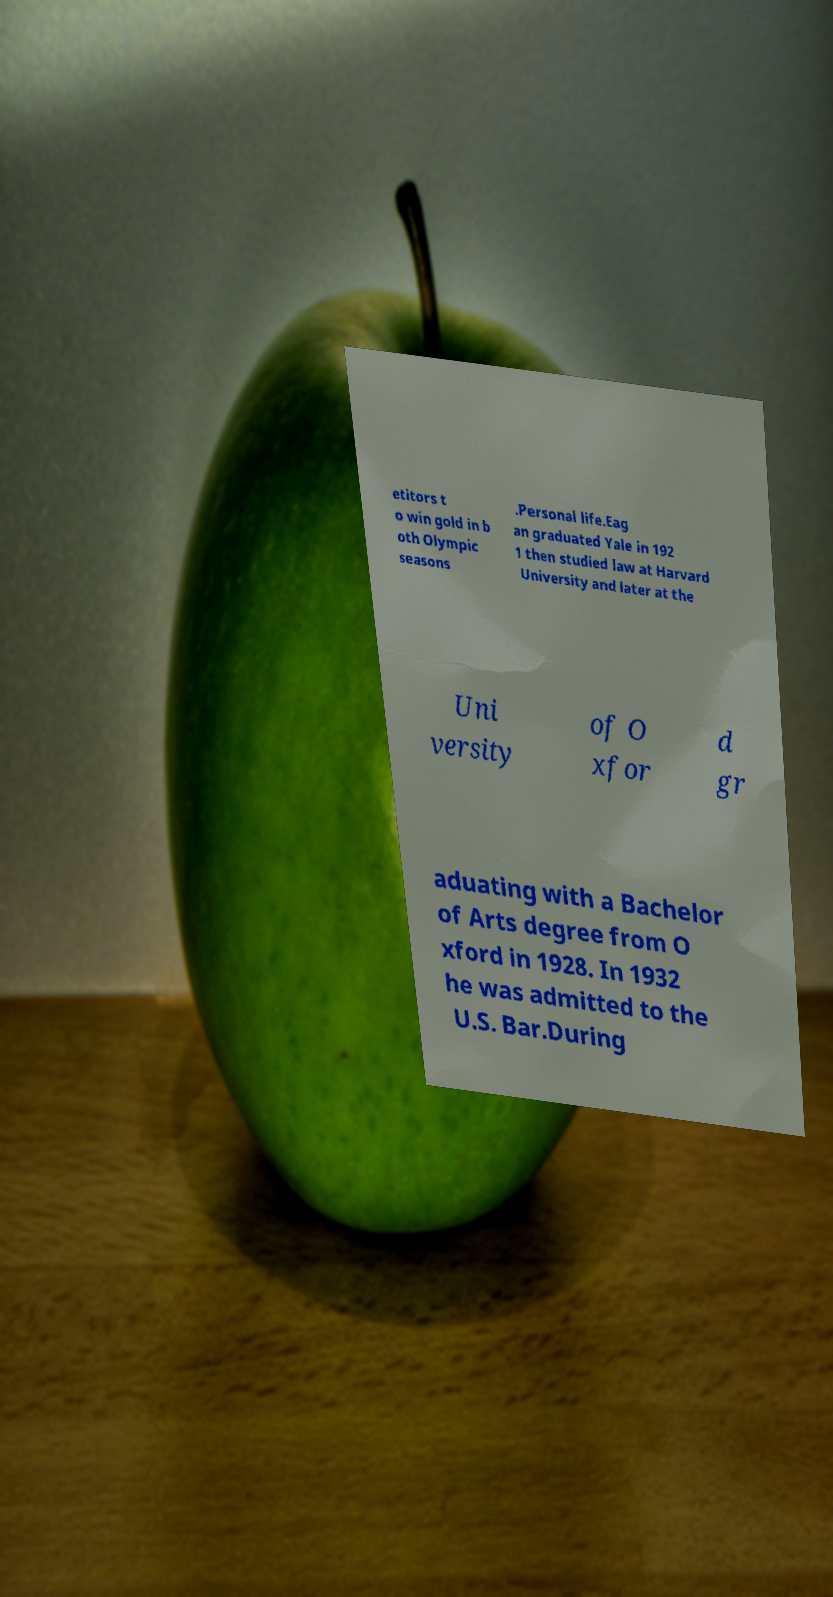There's text embedded in this image that I need extracted. Can you transcribe it verbatim? etitors t o win gold in b oth Olympic seasons .Personal life.Eag an graduated Yale in 192 1 then studied law at Harvard University and later at the Uni versity of O xfor d gr aduating with a Bachelor of Arts degree from O xford in 1928. In 1932 he was admitted to the U.S. Bar.During 